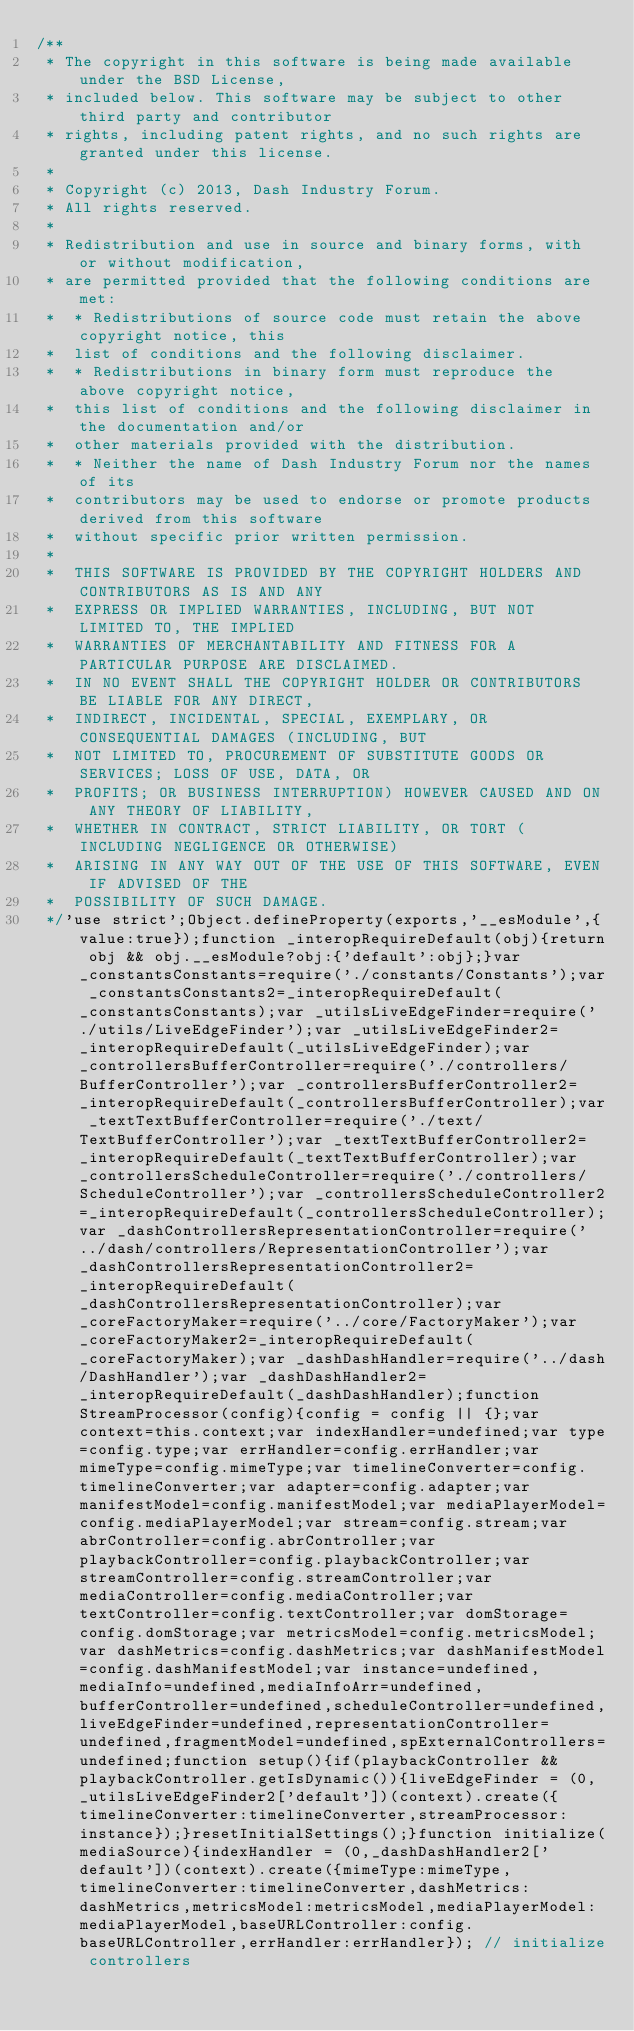<code> <loc_0><loc_0><loc_500><loc_500><_JavaScript_>/**
 * The copyright in this software is being made available under the BSD License,
 * included below. This software may be subject to other third party and contributor
 * rights, including patent rights, and no such rights are granted under this license.
 *
 * Copyright (c) 2013, Dash Industry Forum.
 * All rights reserved.
 *
 * Redistribution and use in source and binary forms, with or without modification,
 * are permitted provided that the following conditions are met:
 *  * Redistributions of source code must retain the above copyright notice, this
 *  list of conditions and the following disclaimer.
 *  * Redistributions in binary form must reproduce the above copyright notice,
 *  this list of conditions and the following disclaimer in the documentation and/or
 *  other materials provided with the distribution.
 *  * Neither the name of Dash Industry Forum nor the names of its
 *  contributors may be used to endorse or promote products derived from this software
 *  without specific prior written permission.
 *
 *  THIS SOFTWARE IS PROVIDED BY THE COPYRIGHT HOLDERS AND CONTRIBUTORS AS IS AND ANY
 *  EXPRESS OR IMPLIED WARRANTIES, INCLUDING, BUT NOT LIMITED TO, THE IMPLIED
 *  WARRANTIES OF MERCHANTABILITY AND FITNESS FOR A PARTICULAR PURPOSE ARE DISCLAIMED.
 *  IN NO EVENT SHALL THE COPYRIGHT HOLDER OR CONTRIBUTORS BE LIABLE FOR ANY DIRECT,
 *  INDIRECT, INCIDENTAL, SPECIAL, EXEMPLARY, OR CONSEQUENTIAL DAMAGES (INCLUDING, BUT
 *  NOT LIMITED TO, PROCUREMENT OF SUBSTITUTE GOODS OR SERVICES; LOSS OF USE, DATA, OR
 *  PROFITS; OR BUSINESS INTERRUPTION) HOWEVER CAUSED AND ON ANY THEORY OF LIABILITY,
 *  WHETHER IN CONTRACT, STRICT LIABILITY, OR TORT (INCLUDING NEGLIGENCE OR OTHERWISE)
 *  ARISING IN ANY WAY OUT OF THE USE OF THIS SOFTWARE, EVEN IF ADVISED OF THE
 *  POSSIBILITY OF SUCH DAMAGE.
 */'use strict';Object.defineProperty(exports,'__esModule',{value:true});function _interopRequireDefault(obj){return obj && obj.__esModule?obj:{'default':obj};}var _constantsConstants=require('./constants/Constants');var _constantsConstants2=_interopRequireDefault(_constantsConstants);var _utilsLiveEdgeFinder=require('./utils/LiveEdgeFinder');var _utilsLiveEdgeFinder2=_interopRequireDefault(_utilsLiveEdgeFinder);var _controllersBufferController=require('./controllers/BufferController');var _controllersBufferController2=_interopRequireDefault(_controllersBufferController);var _textTextBufferController=require('./text/TextBufferController');var _textTextBufferController2=_interopRequireDefault(_textTextBufferController);var _controllersScheduleController=require('./controllers/ScheduleController');var _controllersScheduleController2=_interopRequireDefault(_controllersScheduleController);var _dashControllersRepresentationController=require('../dash/controllers/RepresentationController');var _dashControllersRepresentationController2=_interopRequireDefault(_dashControllersRepresentationController);var _coreFactoryMaker=require('../core/FactoryMaker');var _coreFactoryMaker2=_interopRequireDefault(_coreFactoryMaker);var _dashDashHandler=require('../dash/DashHandler');var _dashDashHandler2=_interopRequireDefault(_dashDashHandler);function StreamProcessor(config){config = config || {};var context=this.context;var indexHandler=undefined;var type=config.type;var errHandler=config.errHandler;var mimeType=config.mimeType;var timelineConverter=config.timelineConverter;var adapter=config.adapter;var manifestModel=config.manifestModel;var mediaPlayerModel=config.mediaPlayerModel;var stream=config.stream;var abrController=config.abrController;var playbackController=config.playbackController;var streamController=config.streamController;var mediaController=config.mediaController;var textController=config.textController;var domStorage=config.domStorage;var metricsModel=config.metricsModel;var dashMetrics=config.dashMetrics;var dashManifestModel=config.dashManifestModel;var instance=undefined,mediaInfo=undefined,mediaInfoArr=undefined,bufferController=undefined,scheduleController=undefined,liveEdgeFinder=undefined,representationController=undefined,fragmentModel=undefined,spExternalControllers=undefined;function setup(){if(playbackController && playbackController.getIsDynamic()){liveEdgeFinder = (0,_utilsLiveEdgeFinder2['default'])(context).create({timelineConverter:timelineConverter,streamProcessor:instance});}resetInitialSettings();}function initialize(mediaSource){indexHandler = (0,_dashDashHandler2['default'])(context).create({mimeType:mimeType,timelineConverter:timelineConverter,dashMetrics:dashMetrics,metricsModel:metricsModel,mediaPlayerModel:mediaPlayerModel,baseURLController:config.baseURLController,errHandler:errHandler}); // initialize controllers</code> 